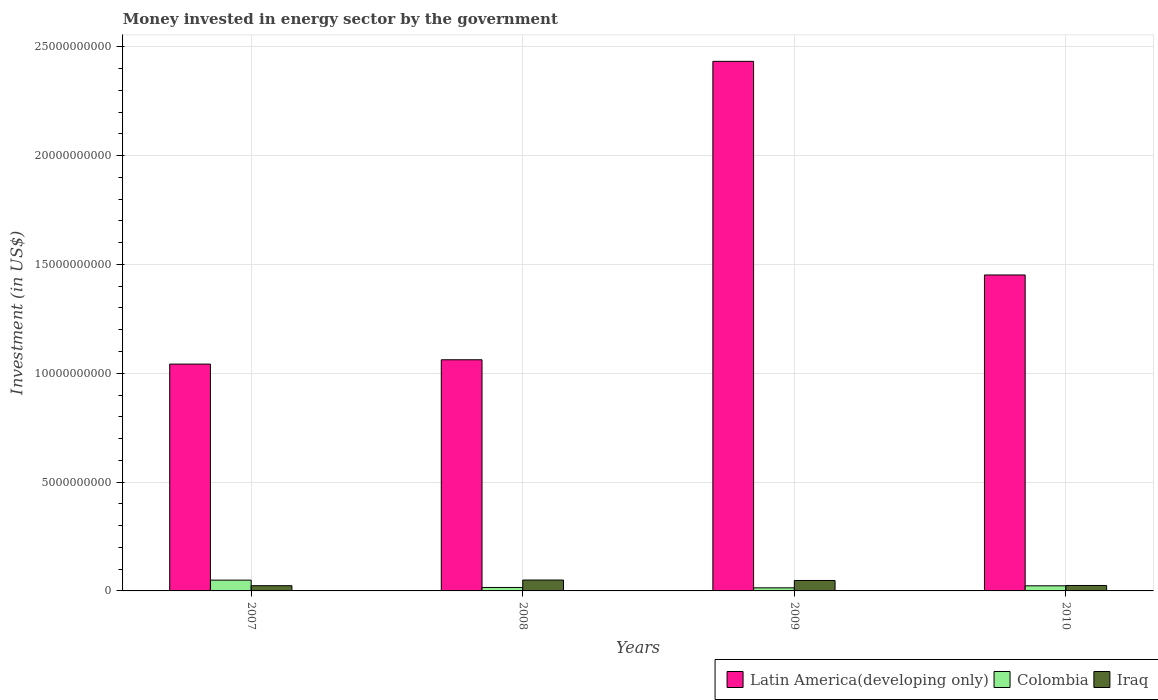How many groups of bars are there?
Your response must be concise. 4. What is the label of the 3rd group of bars from the left?
Make the answer very short. 2009. What is the money spent in energy sector in Iraq in 2010?
Provide a succinct answer. 2.50e+08. Across all years, what is the maximum money spent in energy sector in Iraq?
Keep it short and to the point. 5.00e+08. Across all years, what is the minimum money spent in energy sector in Colombia?
Your answer should be compact. 1.42e+08. What is the total money spent in energy sector in Latin America(developing only) in the graph?
Provide a succinct answer. 5.99e+1. What is the difference between the money spent in energy sector in Iraq in 2009 and that in 2010?
Make the answer very short. 2.30e+08. What is the difference between the money spent in energy sector in Colombia in 2008 and the money spent in energy sector in Latin America(developing only) in 2010?
Ensure brevity in your answer.  -1.44e+1. What is the average money spent in energy sector in Colombia per year?
Your response must be concise. 2.58e+08. In the year 2008, what is the difference between the money spent in energy sector in Latin America(developing only) and money spent in energy sector in Colombia?
Keep it short and to the point. 1.05e+1. Is the money spent in energy sector in Iraq in 2007 less than that in 2008?
Your answer should be very brief. Yes. What is the difference between the highest and the second highest money spent in energy sector in Latin America(developing only)?
Provide a short and direct response. 9.82e+09. What is the difference between the highest and the lowest money spent in energy sector in Latin America(developing only)?
Give a very brief answer. 1.39e+1. In how many years, is the money spent in energy sector in Colombia greater than the average money spent in energy sector in Colombia taken over all years?
Your answer should be compact. 1. Is it the case that in every year, the sum of the money spent in energy sector in Latin America(developing only) and money spent in energy sector in Iraq is greater than the money spent in energy sector in Colombia?
Ensure brevity in your answer.  Yes. How many bars are there?
Give a very brief answer. 12. What is the difference between two consecutive major ticks on the Y-axis?
Make the answer very short. 5.00e+09. Are the values on the major ticks of Y-axis written in scientific E-notation?
Your response must be concise. No. Does the graph contain any zero values?
Your response must be concise. No. Where does the legend appear in the graph?
Offer a very short reply. Bottom right. How many legend labels are there?
Offer a terse response. 3. How are the legend labels stacked?
Keep it short and to the point. Horizontal. What is the title of the graph?
Provide a short and direct response. Money invested in energy sector by the government. Does "Channel Islands" appear as one of the legend labels in the graph?
Make the answer very short. No. What is the label or title of the Y-axis?
Ensure brevity in your answer.  Investment (in US$). What is the Investment (in US$) in Latin America(developing only) in 2007?
Keep it short and to the point. 1.04e+1. What is the Investment (in US$) of Colombia in 2007?
Give a very brief answer. 4.96e+08. What is the Investment (in US$) of Iraq in 2007?
Make the answer very short. 2.40e+08. What is the Investment (in US$) in Latin America(developing only) in 2008?
Make the answer very short. 1.06e+1. What is the Investment (in US$) of Colombia in 2008?
Keep it short and to the point. 1.59e+08. What is the Investment (in US$) of Iraq in 2008?
Your answer should be very brief. 5.00e+08. What is the Investment (in US$) of Latin America(developing only) in 2009?
Make the answer very short. 2.43e+1. What is the Investment (in US$) of Colombia in 2009?
Provide a succinct answer. 1.42e+08. What is the Investment (in US$) of Iraq in 2009?
Give a very brief answer. 4.80e+08. What is the Investment (in US$) of Latin America(developing only) in 2010?
Your answer should be compact. 1.45e+1. What is the Investment (in US$) of Colombia in 2010?
Your answer should be compact. 2.35e+08. What is the Investment (in US$) of Iraq in 2010?
Keep it short and to the point. 2.50e+08. Across all years, what is the maximum Investment (in US$) in Latin America(developing only)?
Make the answer very short. 2.43e+1. Across all years, what is the maximum Investment (in US$) in Colombia?
Your response must be concise. 4.96e+08. Across all years, what is the minimum Investment (in US$) in Latin America(developing only)?
Your response must be concise. 1.04e+1. Across all years, what is the minimum Investment (in US$) in Colombia?
Offer a terse response. 1.42e+08. Across all years, what is the minimum Investment (in US$) of Iraq?
Offer a very short reply. 2.40e+08. What is the total Investment (in US$) of Latin America(developing only) in the graph?
Your answer should be compact. 5.99e+1. What is the total Investment (in US$) in Colombia in the graph?
Keep it short and to the point. 1.03e+09. What is the total Investment (in US$) of Iraq in the graph?
Make the answer very short. 1.47e+09. What is the difference between the Investment (in US$) of Latin America(developing only) in 2007 and that in 2008?
Your answer should be compact. -1.99e+08. What is the difference between the Investment (in US$) of Colombia in 2007 and that in 2008?
Your answer should be very brief. 3.36e+08. What is the difference between the Investment (in US$) of Iraq in 2007 and that in 2008?
Provide a short and direct response. -2.60e+08. What is the difference between the Investment (in US$) of Latin America(developing only) in 2007 and that in 2009?
Give a very brief answer. -1.39e+1. What is the difference between the Investment (in US$) of Colombia in 2007 and that in 2009?
Your answer should be compact. 3.54e+08. What is the difference between the Investment (in US$) in Iraq in 2007 and that in 2009?
Provide a succinct answer. -2.40e+08. What is the difference between the Investment (in US$) in Latin America(developing only) in 2007 and that in 2010?
Keep it short and to the point. -4.09e+09. What is the difference between the Investment (in US$) of Colombia in 2007 and that in 2010?
Your answer should be very brief. 2.61e+08. What is the difference between the Investment (in US$) in Iraq in 2007 and that in 2010?
Keep it short and to the point. -1.00e+07. What is the difference between the Investment (in US$) in Latin America(developing only) in 2008 and that in 2009?
Ensure brevity in your answer.  -1.37e+1. What is the difference between the Investment (in US$) in Colombia in 2008 and that in 2009?
Your answer should be very brief. 1.72e+07. What is the difference between the Investment (in US$) of Latin America(developing only) in 2008 and that in 2010?
Keep it short and to the point. -3.90e+09. What is the difference between the Investment (in US$) in Colombia in 2008 and that in 2010?
Provide a short and direct response. -7.57e+07. What is the difference between the Investment (in US$) in Iraq in 2008 and that in 2010?
Offer a terse response. 2.50e+08. What is the difference between the Investment (in US$) in Latin America(developing only) in 2009 and that in 2010?
Ensure brevity in your answer.  9.82e+09. What is the difference between the Investment (in US$) of Colombia in 2009 and that in 2010?
Your response must be concise. -9.29e+07. What is the difference between the Investment (in US$) of Iraq in 2009 and that in 2010?
Your answer should be compact. 2.30e+08. What is the difference between the Investment (in US$) in Latin America(developing only) in 2007 and the Investment (in US$) in Colombia in 2008?
Offer a terse response. 1.03e+1. What is the difference between the Investment (in US$) of Latin America(developing only) in 2007 and the Investment (in US$) of Iraq in 2008?
Give a very brief answer. 9.92e+09. What is the difference between the Investment (in US$) in Colombia in 2007 and the Investment (in US$) in Iraq in 2008?
Provide a succinct answer. -4.40e+06. What is the difference between the Investment (in US$) of Latin America(developing only) in 2007 and the Investment (in US$) of Colombia in 2009?
Provide a succinct answer. 1.03e+1. What is the difference between the Investment (in US$) of Latin America(developing only) in 2007 and the Investment (in US$) of Iraq in 2009?
Offer a terse response. 9.94e+09. What is the difference between the Investment (in US$) in Colombia in 2007 and the Investment (in US$) in Iraq in 2009?
Keep it short and to the point. 1.56e+07. What is the difference between the Investment (in US$) of Latin America(developing only) in 2007 and the Investment (in US$) of Colombia in 2010?
Provide a short and direct response. 1.02e+1. What is the difference between the Investment (in US$) in Latin America(developing only) in 2007 and the Investment (in US$) in Iraq in 2010?
Ensure brevity in your answer.  1.02e+1. What is the difference between the Investment (in US$) of Colombia in 2007 and the Investment (in US$) of Iraq in 2010?
Provide a succinct answer. 2.46e+08. What is the difference between the Investment (in US$) of Latin America(developing only) in 2008 and the Investment (in US$) of Colombia in 2009?
Provide a short and direct response. 1.05e+1. What is the difference between the Investment (in US$) of Latin America(developing only) in 2008 and the Investment (in US$) of Iraq in 2009?
Provide a short and direct response. 1.01e+1. What is the difference between the Investment (in US$) of Colombia in 2008 and the Investment (in US$) of Iraq in 2009?
Provide a short and direct response. -3.21e+08. What is the difference between the Investment (in US$) in Latin America(developing only) in 2008 and the Investment (in US$) in Colombia in 2010?
Ensure brevity in your answer.  1.04e+1. What is the difference between the Investment (in US$) of Latin America(developing only) in 2008 and the Investment (in US$) of Iraq in 2010?
Make the answer very short. 1.04e+1. What is the difference between the Investment (in US$) of Colombia in 2008 and the Investment (in US$) of Iraq in 2010?
Offer a very short reply. -9.07e+07. What is the difference between the Investment (in US$) in Latin America(developing only) in 2009 and the Investment (in US$) in Colombia in 2010?
Provide a short and direct response. 2.41e+1. What is the difference between the Investment (in US$) in Latin America(developing only) in 2009 and the Investment (in US$) in Iraq in 2010?
Your answer should be compact. 2.41e+1. What is the difference between the Investment (in US$) of Colombia in 2009 and the Investment (in US$) of Iraq in 2010?
Give a very brief answer. -1.08e+08. What is the average Investment (in US$) in Latin America(developing only) per year?
Your response must be concise. 1.50e+1. What is the average Investment (in US$) in Colombia per year?
Offer a terse response. 2.58e+08. What is the average Investment (in US$) in Iraq per year?
Your answer should be compact. 3.68e+08. In the year 2007, what is the difference between the Investment (in US$) in Latin America(developing only) and Investment (in US$) in Colombia?
Offer a very short reply. 9.93e+09. In the year 2007, what is the difference between the Investment (in US$) of Latin America(developing only) and Investment (in US$) of Iraq?
Provide a short and direct response. 1.02e+1. In the year 2007, what is the difference between the Investment (in US$) in Colombia and Investment (in US$) in Iraq?
Your response must be concise. 2.56e+08. In the year 2008, what is the difference between the Investment (in US$) of Latin America(developing only) and Investment (in US$) of Colombia?
Your answer should be compact. 1.05e+1. In the year 2008, what is the difference between the Investment (in US$) of Latin America(developing only) and Investment (in US$) of Iraq?
Provide a succinct answer. 1.01e+1. In the year 2008, what is the difference between the Investment (in US$) in Colombia and Investment (in US$) in Iraq?
Offer a terse response. -3.41e+08. In the year 2009, what is the difference between the Investment (in US$) of Latin America(developing only) and Investment (in US$) of Colombia?
Make the answer very short. 2.42e+1. In the year 2009, what is the difference between the Investment (in US$) of Latin America(developing only) and Investment (in US$) of Iraq?
Make the answer very short. 2.39e+1. In the year 2009, what is the difference between the Investment (in US$) of Colombia and Investment (in US$) of Iraq?
Keep it short and to the point. -3.38e+08. In the year 2010, what is the difference between the Investment (in US$) in Latin America(developing only) and Investment (in US$) in Colombia?
Your answer should be compact. 1.43e+1. In the year 2010, what is the difference between the Investment (in US$) in Latin America(developing only) and Investment (in US$) in Iraq?
Ensure brevity in your answer.  1.43e+1. In the year 2010, what is the difference between the Investment (in US$) in Colombia and Investment (in US$) in Iraq?
Your answer should be very brief. -1.50e+07. What is the ratio of the Investment (in US$) in Latin America(developing only) in 2007 to that in 2008?
Ensure brevity in your answer.  0.98. What is the ratio of the Investment (in US$) of Colombia in 2007 to that in 2008?
Offer a terse response. 3.11. What is the ratio of the Investment (in US$) in Iraq in 2007 to that in 2008?
Ensure brevity in your answer.  0.48. What is the ratio of the Investment (in US$) in Latin America(developing only) in 2007 to that in 2009?
Your answer should be very brief. 0.43. What is the ratio of the Investment (in US$) of Colombia in 2007 to that in 2009?
Give a very brief answer. 3.49. What is the ratio of the Investment (in US$) in Latin America(developing only) in 2007 to that in 2010?
Give a very brief answer. 0.72. What is the ratio of the Investment (in US$) of Colombia in 2007 to that in 2010?
Provide a short and direct response. 2.11. What is the ratio of the Investment (in US$) of Latin America(developing only) in 2008 to that in 2009?
Make the answer very short. 0.44. What is the ratio of the Investment (in US$) of Colombia in 2008 to that in 2009?
Offer a very short reply. 1.12. What is the ratio of the Investment (in US$) of Iraq in 2008 to that in 2009?
Offer a very short reply. 1.04. What is the ratio of the Investment (in US$) of Latin America(developing only) in 2008 to that in 2010?
Your answer should be compact. 0.73. What is the ratio of the Investment (in US$) of Colombia in 2008 to that in 2010?
Keep it short and to the point. 0.68. What is the ratio of the Investment (in US$) in Iraq in 2008 to that in 2010?
Offer a terse response. 2. What is the ratio of the Investment (in US$) of Latin America(developing only) in 2009 to that in 2010?
Offer a very short reply. 1.68. What is the ratio of the Investment (in US$) of Colombia in 2009 to that in 2010?
Your answer should be compact. 0.6. What is the ratio of the Investment (in US$) in Iraq in 2009 to that in 2010?
Offer a very short reply. 1.92. What is the difference between the highest and the second highest Investment (in US$) of Latin America(developing only)?
Ensure brevity in your answer.  9.82e+09. What is the difference between the highest and the second highest Investment (in US$) in Colombia?
Your response must be concise. 2.61e+08. What is the difference between the highest and the lowest Investment (in US$) of Latin America(developing only)?
Give a very brief answer. 1.39e+1. What is the difference between the highest and the lowest Investment (in US$) in Colombia?
Ensure brevity in your answer.  3.54e+08. What is the difference between the highest and the lowest Investment (in US$) of Iraq?
Your response must be concise. 2.60e+08. 